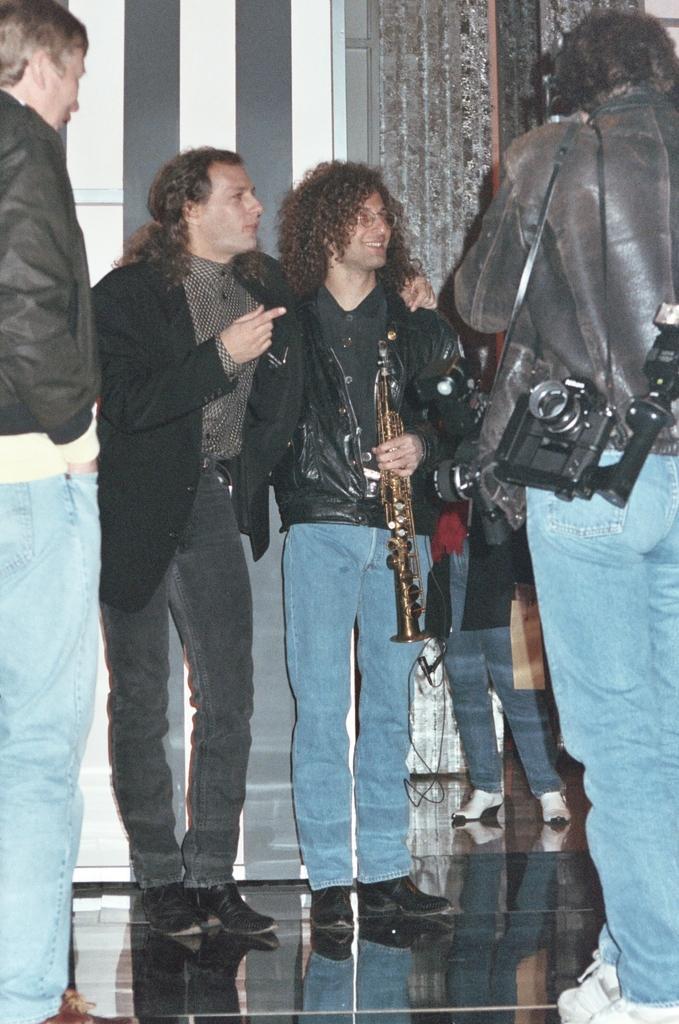Could you give a brief overview of what you see in this image? In the image we can see there are people standing, wearing clothes, shoes and some of them are carrying objects. Here we can see the floor and the musical instrument. 